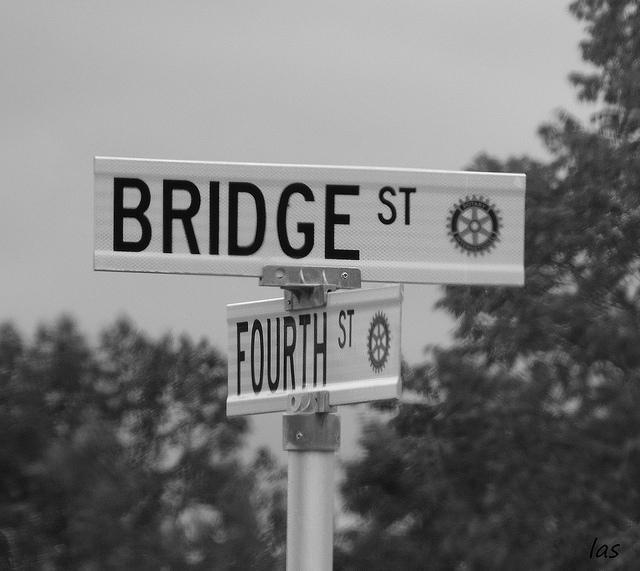How many ways can you go here?
Give a very brief answer. 2. 